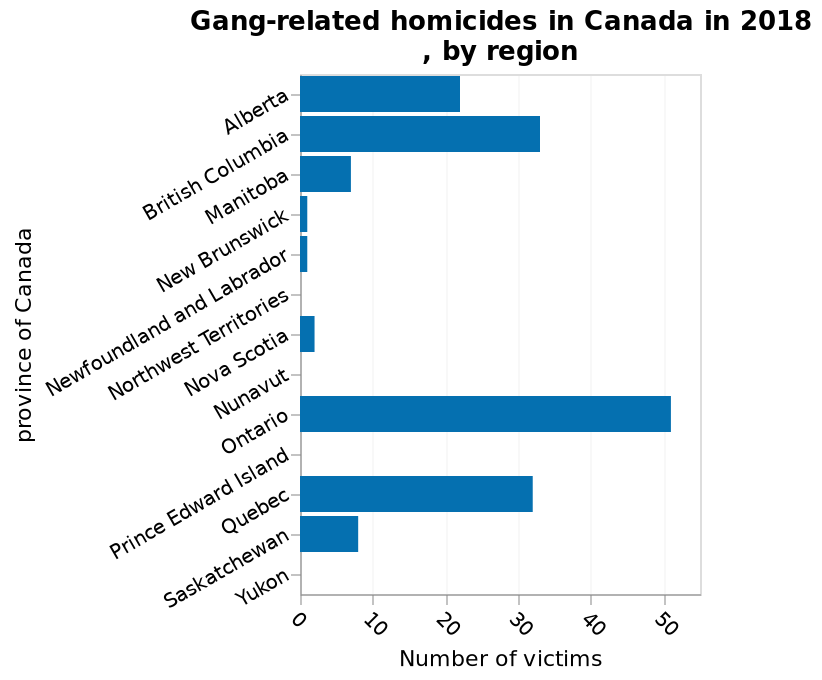<image>
What is the range of values shown on the x-axis? The range of values shown on the x-axis is from 0 to 50. What is the title of the bar chart?  The title of the bar chart is "Gang-related homicides in Canada in 2018, by region." What does the x-axis measure in the bar chart?  The x-axis measures the number of victims on a linear scale from 0 to 50. 